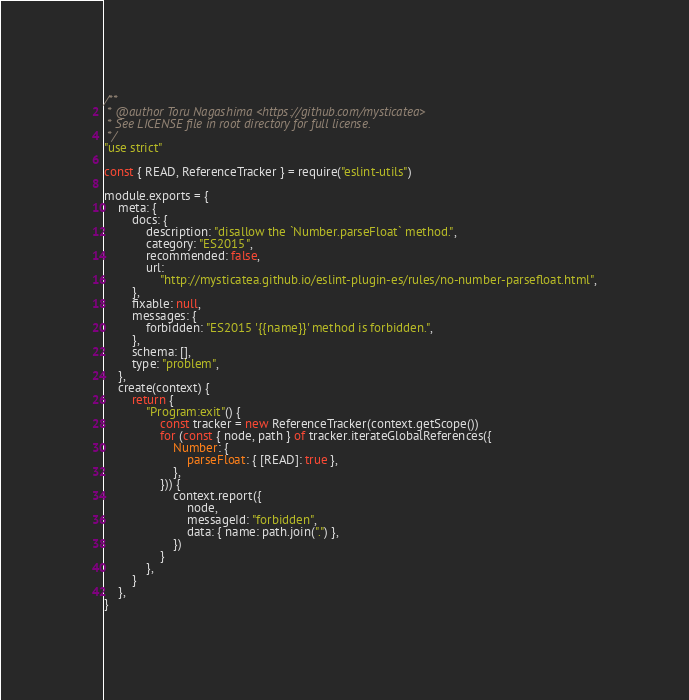Convert code to text. <code><loc_0><loc_0><loc_500><loc_500><_JavaScript_>/**
 * @author Toru Nagashima <https://github.com/mysticatea>
 * See LICENSE file in root directory for full license.
 */
"use strict"

const { READ, ReferenceTracker } = require("eslint-utils")

module.exports = {
    meta: {
        docs: {
            description: "disallow the `Number.parseFloat` method.",
            category: "ES2015",
            recommended: false,
            url:
                "http://mysticatea.github.io/eslint-plugin-es/rules/no-number-parsefloat.html",
        },
        fixable: null,
        messages: {
            forbidden: "ES2015 '{{name}}' method is forbidden.",
        },
        schema: [],
        type: "problem",
    },
    create(context) {
        return {
            "Program:exit"() {
                const tracker = new ReferenceTracker(context.getScope())
                for (const { node, path } of tracker.iterateGlobalReferences({
                    Number: {
                        parseFloat: { [READ]: true },
                    },
                })) {
                    context.report({
                        node,
                        messageId: "forbidden",
                        data: { name: path.join(".") },
                    })
                }
            },
        }
    },
}
</code> 